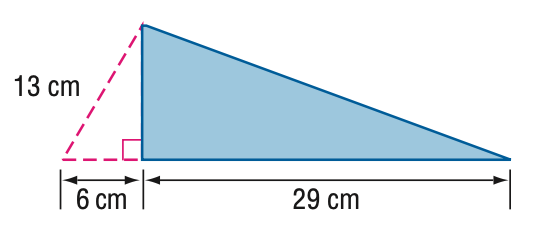Answer the mathemtical geometry problem and directly provide the correct option letter.
Question: Find the area of the triangle.
Choices: A: 167.2 B: 207.6 C: 334.4 D: 415.2 A 